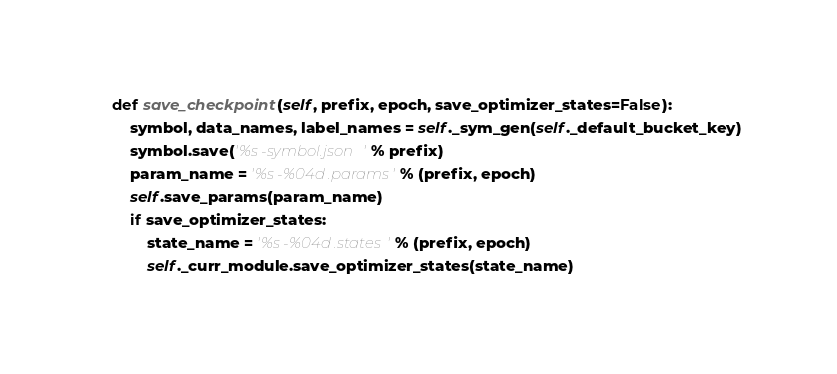Convert code to text. <code><loc_0><loc_0><loc_500><loc_500><_Python_>
    def save_checkpoint(self, prefix, epoch, save_optimizer_states=False):
        symbol, data_names, label_names = self._sym_gen(self._default_bucket_key)
        symbol.save('%s-symbol.json' % prefix)
        param_name = '%s-%04d.params' % (prefix, epoch)
        self.save_params(param_name)
        if save_optimizer_states:
            state_name = '%s-%04d.states' % (prefix, epoch)
            self._curr_module.save_optimizer_states(state_name)</code> 